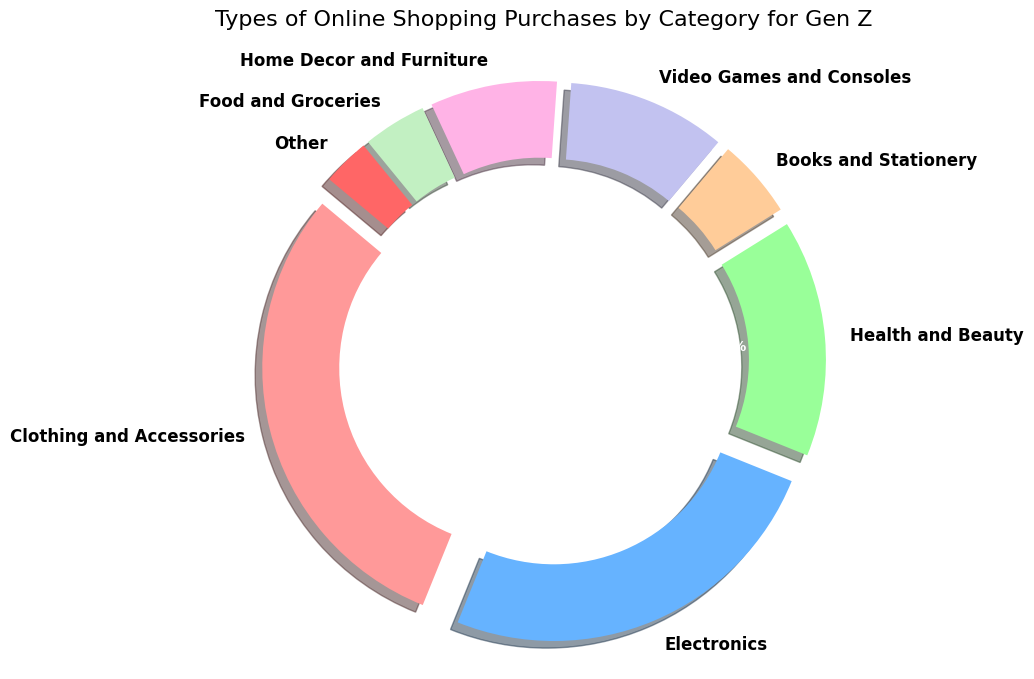What category has the largest percentage of online shopping purchases for Gen Z? Look at the figure's labels and percentages. The largest section should be visually larger and labeled with the highest percentage.
Answer: Clothing and Accessories Which two categories together make up the largest portion of online shopping purchases for Gen Z? Identify the sections with the highest percentages and sum their values. Start with the largest section, then add the next largest until the highest combined value is achieved.
Answer: Clothing and Accessories and Electronics What is the combined percentage for the categories 'Books and Stationery' and 'Food and Groceries'? Find the percentages for 'Books and Stationery' and 'Food and Groceries', then add these together. 5% + 4% = 9%
Answer: 9% How does the spending on 'Health and Beauty' compare to 'Home Decor and Furniture'? Compare the percentages provided for the two categories. 'Health and Beauty' has 15% and 'Home Decor and Furniture' has 8%.
Answer: Higher Which category has a smaller share: 'Video Games and Consoles' or 'Books and Stationery'? Examine the percentages listed for both categories and determine which one is less. 'Video Games and Consoles' is 10% and 'Books and Stationery' is 5%.
Answer: Books and Stationery How does the percentage of 'Electronics' purchases compare to the sum of 'Home Decor and Furniture' and 'Food and Groceries'? Determine the percent for 'Electronics' and sum the percentages for 'Home Decor and Furniture' and 'Food and Groceries'. Compare the two resulting numbers. 'Electronics' is 25%, and 'Home Decor and Furniture' and 'Food and Groceries' together is 8% + 4% = 12%.
Answer: Greater What percentage does the 'Other' category contribute to the total? Locate the percentage for the 'Other' category, which is visually represented in the figure.
Answer: 3% Are 'Electronics' purchases more than double the 'Health and Beauty' purchases for Gen Z? Compare the percentage for 'Electronics' (25%) with twice the percentage for 'Health and Beauty' (2 * 15% = 30%).
Answer: No 